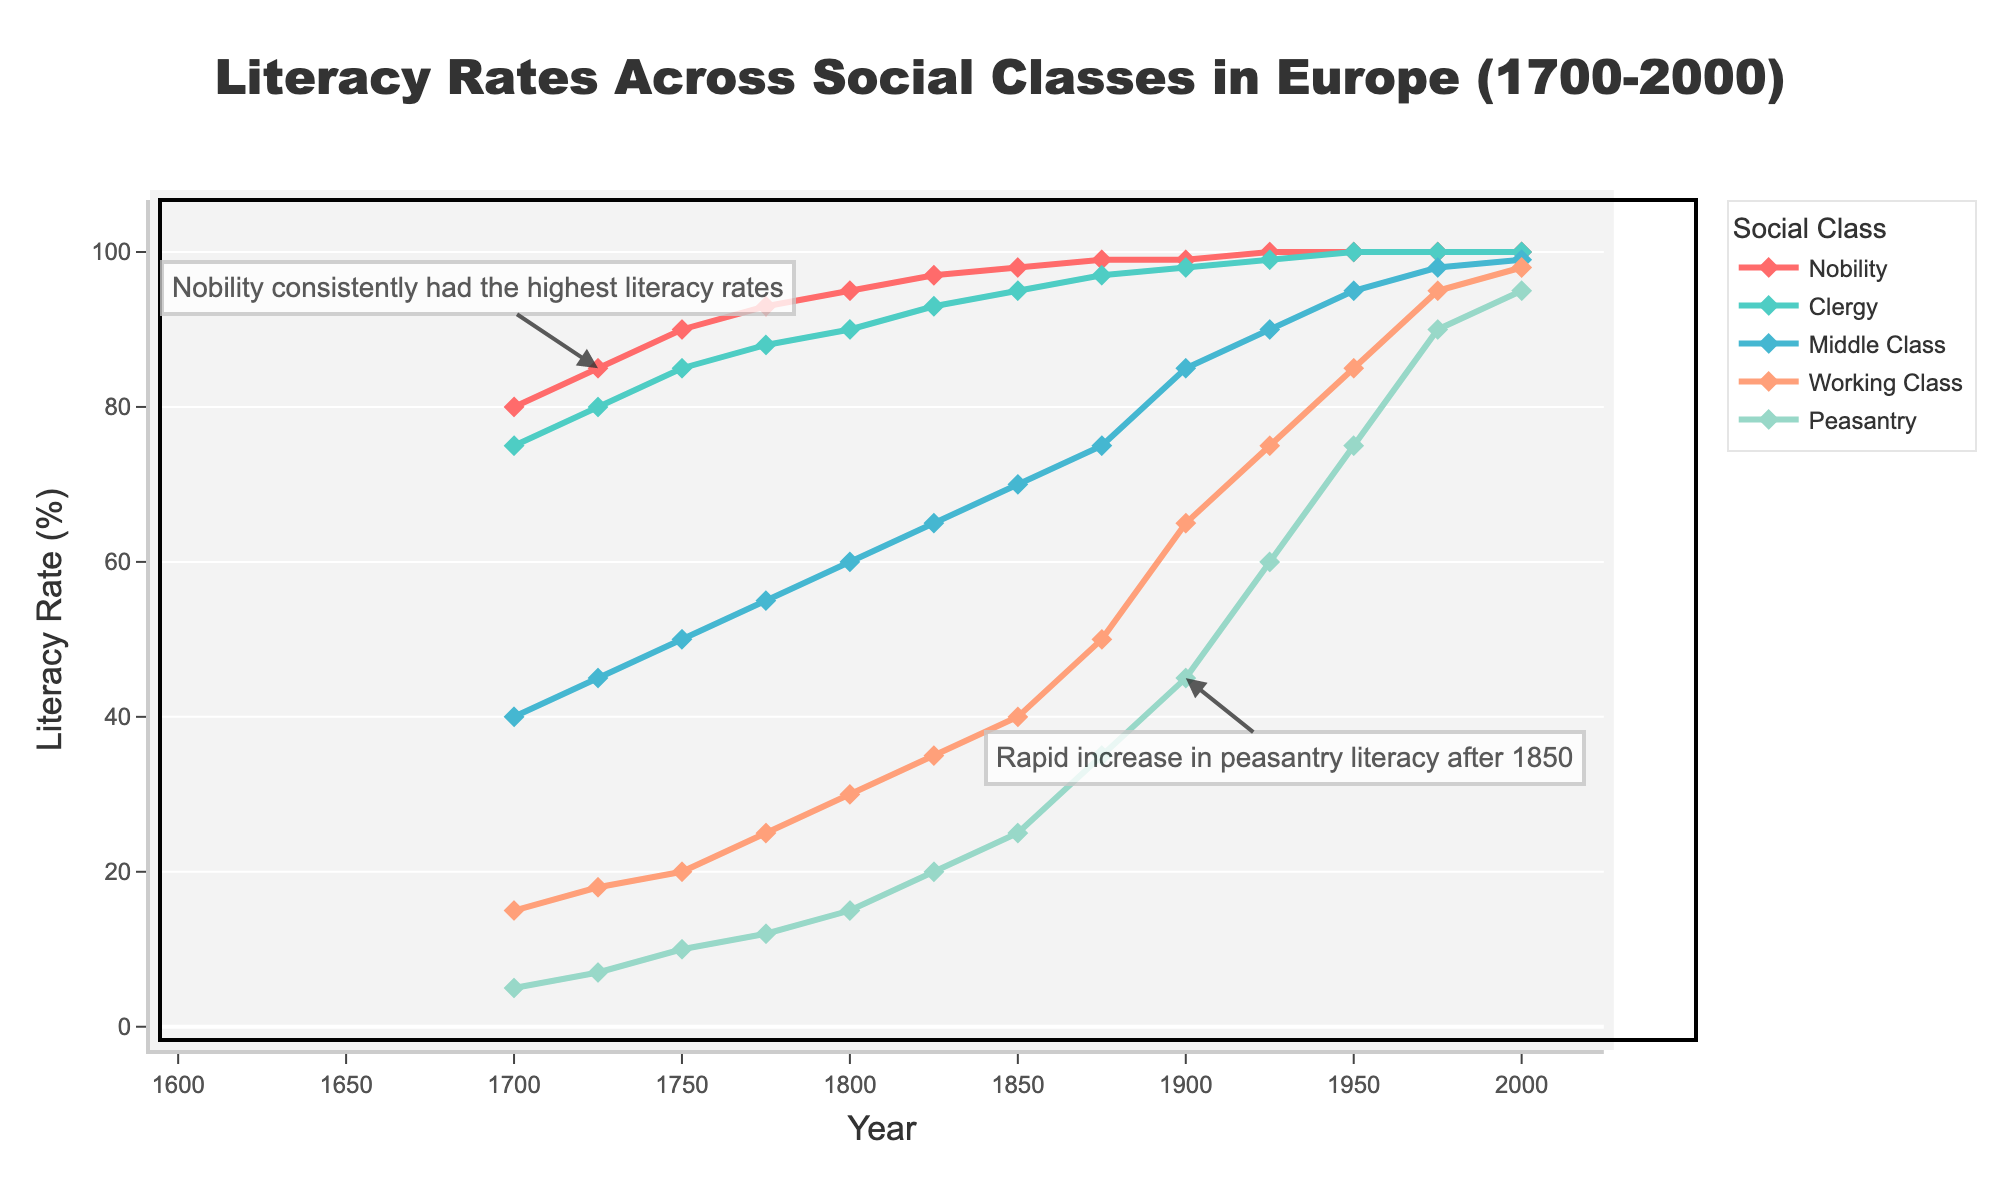What is the overall trend in literacy rates for the nobility from 1700 to 2000? The nobility's literacy rate starts at 80% in 1700 and steadily increases to 100% by 1925, maintaining this level until 2000. This indicates a consistent upward trend in literacy rates for the nobility throughout the period.
Answer: Steadily increasing Which social class experienced the most rapid increase in literacy rate between 1850 and 1900? From 1850 to 1900, the peasantry's literacy rate increased from 25% to 45%, which is a 20 percentage point increase. This is a more rapid increase compared to other social classes in the same period.
Answer: Peasantry By how much did the literacy rate of the working class improve from 1700 to 2000? The working class had a literacy rate of 15% in 1700 and it increased to 98% in 2000. The improvement is calculated as 98% - 15% = 83%.
Answer: 83% At what period did all social classes, except the peasantry, achieve a literacy rate of 90% or higher? This occurs around 1925 when the nobility is at 100%, clergy at 99%, middle class at 90%, and working class at 75%. The peasantry reaches 60% literacy at this time, while all other classes surpass 90%.
Answer: 1925 Compare the literacy rates of the middle class and the working class in 1900. In 1900, the middle class has a literacy rate of 85%, while the working class has a literacy rate of 65%. The middle class has a higher literacy rate by 20 percentage points.
Answer: The middle class is higher by 20 percentage points What is the difference in literacy rates between the clergy and peasantry in 1750? In 1750, the clergy's literacy rate is 85%, while the peasantry's is 10%. The difference between them is 85% - 10% = 75%.
Answer: 75% Which social class's literacy rate was closest to 50% in 1875? In 1875, the middle class had a literacy rate of 75%, working class at 50%, and peasantry at 35%. The working class's literacy rate is exactly 50%.
Answer: Working class What was the literacy rate of the clergy in 1950 and how does it compare to the working class at the same time? In 1950, the clergy had a literacy rate of 100%, while the working class had a rate of 85%. The clergy had a higher literacy rate by 15 percentage points.
Answer: Clergy is higher by 15 percentage points Between 1700 and 1825, which social class experienced the smallest increase in literacy rates? Between 1700 and 1825, the nobility's literacy rate increased from 80% to 97%, which is a 17 percentage point increase. Other classes such as the clergy and middle class had larger increases. Therefore, the nobility experienced the smallest increase.
Answer: Nobility 